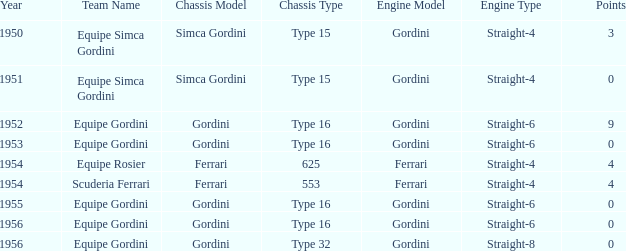Could you help me parse every detail presented in this table? {'header': ['Year', 'Team Name', 'Chassis Model', 'Chassis Type', 'Engine Model', 'Engine Type', 'Points'], 'rows': [['1950', 'Equipe Simca Gordini', 'Simca Gordini', 'Type 15', 'Gordini', 'Straight-4', '3'], ['1951', 'Equipe Simca Gordini', 'Simca Gordini', 'Type 15', 'Gordini', 'Straight-4', '0'], ['1952', 'Equipe Gordini', 'Gordini', 'Type 16', 'Gordini', 'Straight-6', '9'], ['1953', 'Equipe Gordini', 'Gordini', 'Type 16', 'Gordini', 'Straight-6', '0'], ['1954', 'Equipe Rosier', 'Ferrari', '625', 'Ferrari', 'Straight-4', '4'], ['1954', 'Scuderia Ferrari', 'Ferrari', '553', 'Ferrari', 'Straight-4', '4'], ['1955', 'Equipe Gordini', 'Gordini', 'Type 16', 'Gordini', 'Straight-6', '0'], ['1956', 'Equipe Gordini', 'Gordini', 'Type 16', 'Gordini', 'Straight-6', '0'], ['1956', 'Equipe Gordini', 'Gordini', 'Type 32', 'Gordini', 'Straight-8', '0']]} Before 1956, what Chassis has Gordini Straight-4 engine with 3 points? Simca Gordini Type 15. 